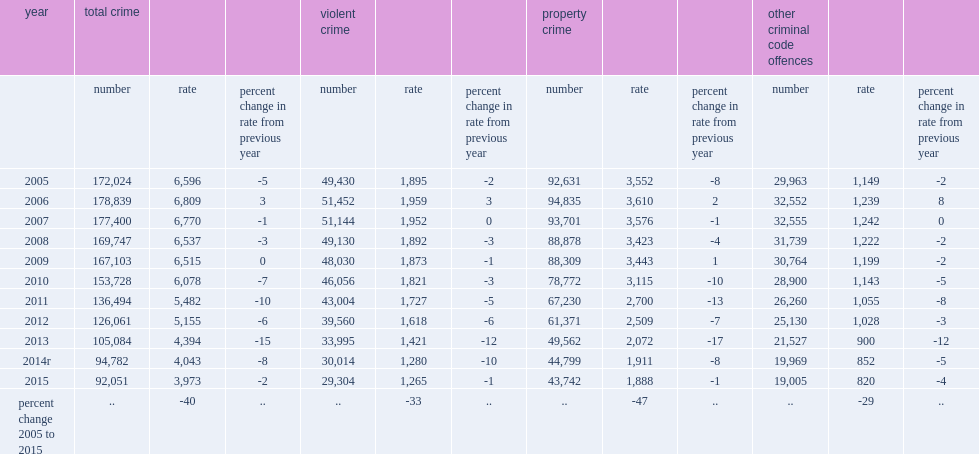Would you be able to parse every entry in this table? {'header': ['year', 'total crime', '', '', 'violent crime', '', '', 'property crime', '', '', 'other criminal code offences', '', ''], 'rows': [['', 'number', 'rate', 'percent change in rate from previous year', 'number', 'rate', 'percent change in rate from previous year', 'number', 'rate', 'percent change in rate from previous year', 'number', 'rate', 'percent change in rate from previous year'], ['2005', '172,024', '6,596', '-5', '49,430', '1,895', '-2', '92,631', '3,552', '-8', '29,963', '1,149', '-2'], ['2006', '178,839', '6,809', '3', '51,452', '1,959', '3', '94,835', '3,610', '2', '32,552', '1,239', '8'], ['2007', '177,400', '6,770', '-1', '51,144', '1,952', '0', '93,701', '3,576', '-1', '32,555', '1,242', '0'], ['2008', '169,747', '6,537', '-3', '49,130', '1,892', '-3', '88,878', '3,423', '-4', '31,739', '1,222', '-2'], ['2009', '167,103', '6,515', '0', '48,030', '1,873', '-1', '88,309', '3,443', '1', '30,764', '1,199', '-2'], ['2010', '153,728', '6,078', '-7', '46,056', '1,821', '-3', '78,772', '3,115', '-10', '28,900', '1,143', '-5'], ['2011', '136,494', '5,482', '-10', '43,004', '1,727', '-5', '67,230', '2,700', '-13', '26,260', '1,055', '-8'], ['2012', '126,061', '5,155', '-6', '39,560', '1,618', '-6', '61,371', '2,509', '-7', '25,130', '1,028', '-3'], ['2013', '105,084', '4,394', '-15', '33,995', '1,421', '-12', '49,562', '2,072', '-17', '21,527', '900', '-12'], ['2014r', '94,782', '4,043', '-8', '30,014', '1,280', '-10', '44,799', '1,911', '-8', '19,969', '852', '-5'], ['2015', '92,051', '3,973', '-2', '29,304', '1,265', '-1', '43,742', '1,888', '-1', '19,005', '820', '-4'], ['percent change 2005 to 2015', '..', '-40', '..', '..', '-33', '..', '..', '-47', '..', '..', '-29', '..']]} In addition, what is the rate of youth of total crime accused by police down in 2015? 2. In addition, what is the rate of total crime accused by police per 100,000 youth population in 2015? 3973.0. 